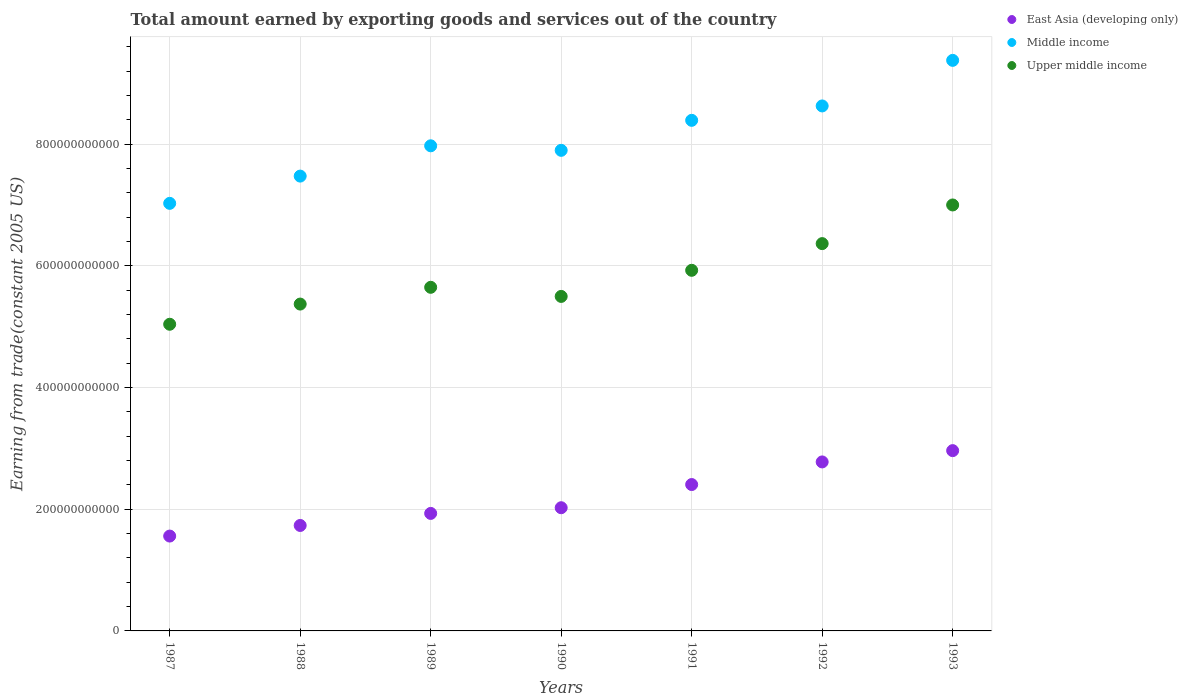What is the total amount earned by exporting goods and services in Upper middle income in 1992?
Offer a terse response. 6.36e+11. Across all years, what is the maximum total amount earned by exporting goods and services in East Asia (developing only)?
Your response must be concise. 2.96e+11. Across all years, what is the minimum total amount earned by exporting goods and services in Upper middle income?
Your response must be concise. 5.04e+11. In which year was the total amount earned by exporting goods and services in East Asia (developing only) minimum?
Provide a succinct answer. 1987. What is the total total amount earned by exporting goods and services in Upper middle income in the graph?
Ensure brevity in your answer.  4.08e+12. What is the difference between the total amount earned by exporting goods and services in Upper middle income in 1988 and that in 1991?
Offer a very short reply. -5.55e+1. What is the difference between the total amount earned by exporting goods and services in East Asia (developing only) in 1989 and the total amount earned by exporting goods and services in Middle income in 1987?
Your answer should be compact. -5.10e+11. What is the average total amount earned by exporting goods and services in Middle income per year?
Give a very brief answer. 8.11e+11. In the year 1990, what is the difference between the total amount earned by exporting goods and services in East Asia (developing only) and total amount earned by exporting goods and services in Upper middle income?
Your response must be concise. -3.47e+11. In how many years, is the total amount earned by exporting goods and services in East Asia (developing only) greater than 760000000000 US$?
Ensure brevity in your answer.  0. What is the ratio of the total amount earned by exporting goods and services in Middle income in 1991 to that in 1992?
Provide a succinct answer. 0.97. Is the total amount earned by exporting goods and services in Upper middle income in 1987 less than that in 1992?
Give a very brief answer. Yes. What is the difference between the highest and the second highest total amount earned by exporting goods and services in Upper middle income?
Keep it short and to the point. 6.35e+1. What is the difference between the highest and the lowest total amount earned by exporting goods and services in Middle income?
Offer a very short reply. 2.35e+11. In how many years, is the total amount earned by exporting goods and services in Upper middle income greater than the average total amount earned by exporting goods and services in Upper middle income taken over all years?
Your response must be concise. 3. Is the sum of the total amount earned by exporting goods and services in East Asia (developing only) in 1987 and 1988 greater than the maximum total amount earned by exporting goods and services in Middle income across all years?
Offer a very short reply. No. Is it the case that in every year, the sum of the total amount earned by exporting goods and services in East Asia (developing only) and total amount earned by exporting goods and services in Upper middle income  is greater than the total amount earned by exporting goods and services in Middle income?
Your answer should be compact. No. How many years are there in the graph?
Provide a short and direct response. 7. What is the difference between two consecutive major ticks on the Y-axis?
Your response must be concise. 2.00e+11. How are the legend labels stacked?
Your answer should be very brief. Vertical. What is the title of the graph?
Provide a succinct answer. Total amount earned by exporting goods and services out of the country. Does "Hong Kong" appear as one of the legend labels in the graph?
Provide a short and direct response. No. What is the label or title of the X-axis?
Give a very brief answer. Years. What is the label or title of the Y-axis?
Provide a short and direct response. Earning from trade(constant 2005 US). What is the Earning from trade(constant 2005 US) in East Asia (developing only) in 1987?
Give a very brief answer. 1.56e+11. What is the Earning from trade(constant 2005 US) in Middle income in 1987?
Your answer should be compact. 7.03e+11. What is the Earning from trade(constant 2005 US) in Upper middle income in 1987?
Ensure brevity in your answer.  5.04e+11. What is the Earning from trade(constant 2005 US) in East Asia (developing only) in 1988?
Your answer should be very brief. 1.73e+11. What is the Earning from trade(constant 2005 US) in Middle income in 1988?
Your answer should be very brief. 7.47e+11. What is the Earning from trade(constant 2005 US) of Upper middle income in 1988?
Your answer should be very brief. 5.37e+11. What is the Earning from trade(constant 2005 US) in East Asia (developing only) in 1989?
Your response must be concise. 1.93e+11. What is the Earning from trade(constant 2005 US) of Middle income in 1989?
Keep it short and to the point. 7.97e+11. What is the Earning from trade(constant 2005 US) in Upper middle income in 1989?
Provide a succinct answer. 5.65e+11. What is the Earning from trade(constant 2005 US) in East Asia (developing only) in 1990?
Make the answer very short. 2.02e+11. What is the Earning from trade(constant 2005 US) of Middle income in 1990?
Keep it short and to the point. 7.90e+11. What is the Earning from trade(constant 2005 US) of Upper middle income in 1990?
Offer a very short reply. 5.50e+11. What is the Earning from trade(constant 2005 US) of East Asia (developing only) in 1991?
Your answer should be compact. 2.41e+11. What is the Earning from trade(constant 2005 US) of Middle income in 1991?
Provide a succinct answer. 8.39e+11. What is the Earning from trade(constant 2005 US) in Upper middle income in 1991?
Ensure brevity in your answer.  5.93e+11. What is the Earning from trade(constant 2005 US) of East Asia (developing only) in 1992?
Provide a short and direct response. 2.78e+11. What is the Earning from trade(constant 2005 US) in Middle income in 1992?
Provide a short and direct response. 8.63e+11. What is the Earning from trade(constant 2005 US) in Upper middle income in 1992?
Offer a terse response. 6.36e+11. What is the Earning from trade(constant 2005 US) in East Asia (developing only) in 1993?
Ensure brevity in your answer.  2.96e+11. What is the Earning from trade(constant 2005 US) of Middle income in 1993?
Offer a terse response. 9.38e+11. What is the Earning from trade(constant 2005 US) of Upper middle income in 1993?
Make the answer very short. 7.00e+11. Across all years, what is the maximum Earning from trade(constant 2005 US) in East Asia (developing only)?
Make the answer very short. 2.96e+11. Across all years, what is the maximum Earning from trade(constant 2005 US) of Middle income?
Ensure brevity in your answer.  9.38e+11. Across all years, what is the maximum Earning from trade(constant 2005 US) in Upper middle income?
Offer a very short reply. 7.00e+11. Across all years, what is the minimum Earning from trade(constant 2005 US) of East Asia (developing only)?
Give a very brief answer. 1.56e+11. Across all years, what is the minimum Earning from trade(constant 2005 US) in Middle income?
Give a very brief answer. 7.03e+11. Across all years, what is the minimum Earning from trade(constant 2005 US) of Upper middle income?
Your response must be concise. 5.04e+11. What is the total Earning from trade(constant 2005 US) of East Asia (developing only) in the graph?
Keep it short and to the point. 1.54e+12. What is the total Earning from trade(constant 2005 US) in Middle income in the graph?
Give a very brief answer. 5.68e+12. What is the total Earning from trade(constant 2005 US) of Upper middle income in the graph?
Keep it short and to the point. 4.08e+12. What is the difference between the Earning from trade(constant 2005 US) in East Asia (developing only) in 1987 and that in 1988?
Provide a short and direct response. -1.74e+1. What is the difference between the Earning from trade(constant 2005 US) of Middle income in 1987 and that in 1988?
Ensure brevity in your answer.  -4.48e+1. What is the difference between the Earning from trade(constant 2005 US) in Upper middle income in 1987 and that in 1988?
Make the answer very short. -3.32e+1. What is the difference between the Earning from trade(constant 2005 US) of East Asia (developing only) in 1987 and that in 1989?
Offer a terse response. -3.72e+1. What is the difference between the Earning from trade(constant 2005 US) of Middle income in 1987 and that in 1989?
Provide a short and direct response. -9.46e+1. What is the difference between the Earning from trade(constant 2005 US) in Upper middle income in 1987 and that in 1989?
Make the answer very short. -6.07e+1. What is the difference between the Earning from trade(constant 2005 US) of East Asia (developing only) in 1987 and that in 1990?
Offer a very short reply. -4.66e+1. What is the difference between the Earning from trade(constant 2005 US) in Middle income in 1987 and that in 1990?
Your answer should be very brief. -8.71e+1. What is the difference between the Earning from trade(constant 2005 US) in Upper middle income in 1987 and that in 1990?
Offer a terse response. -4.58e+1. What is the difference between the Earning from trade(constant 2005 US) in East Asia (developing only) in 1987 and that in 1991?
Make the answer very short. -8.47e+1. What is the difference between the Earning from trade(constant 2005 US) in Middle income in 1987 and that in 1991?
Provide a succinct answer. -1.36e+11. What is the difference between the Earning from trade(constant 2005 US) of Upper middle income in 1987 and that in 1991?
Give a very brief answer. -8.87e+1. What is the difference between the Earning from trade(constant 2005 US) in East Asia (developing only) in 1987 and that in 1992?
Give a very brief answer. -1.22e+11. What is the difference between the Earning from trade(constant 2005 US) of Middle income in 1987 and that in 1992?
Give a very brief answer. -1.60e+11. What is the difference between the Earning from trade(constant 2005 US) in Upper middle income in 1987 and that in 1992?
Keep it short and to the point. -1.33e+11. What is the difference between the Earning from trade(constant 2005 US) in East Asia (developing only) in 1987 and that in 1993?
Give a very brief answer. -1.40e+11. What is the difference between the Earning from trade(constant 2005 US) in Middle income in 1987 and that in 1993?
Make the answer very short. -2.35e+11. What is the difference between the Earning from trade(constant 2005 US) in Upper middle income in 1987 and that in 1993?
Your answer should be very brief. -1.96e+11. What is the difference between the Earning from trade(constant 2005 US) of East Asia (developing only) in 1988 and that in 1989?
Provide a short and direct response. -1.98e+1. What is the difference between the Earning from trade(constant 2005 US) of Middle income in 1988 and that in 1989?
Make the answer very short. -4.98e+1. What is the difference between the Earning from trade(constant 2005 US) in Upper middle income in 1988 and that in 1989?
Provide a succinct answer. -2.75e+1. What is the difference between the Earning from trade(constant 2005 US) in East Asia (developing only) in 1988 and that in 1990?
Keep it short and to the point. -2.92e+1. What is the difference between the Earning from trade(constant 2005 US) of Middle income in 1988 and that in 1990?
Provide a succinct answer. -4.23e+1. What is the difference between the Earning from trade(constant 2005 US) in Upper middle income in 1988 and that in 1990?
Ensure brevity in your answer.  -1.26e+1. What is the difference between the Earning from trade(constant 2005 US) in East Asia (developing only) in 1988 and that in 1991?
Offer a terse response. -6.72e+1. What is the difference between the Earning from trade(constant 2005 US) of Middle income in 1988 and that in 1991?
Make the answer very short. -9.16e+1. What is the difference between the Earning from trade(constant 2005 US) of Upper middle income in 1988 and that in 1991?
Offer a very short reply. -5.55e+1. What is the difference between the Earning from trade(constant 2005 US) in East Asia (developing only) in 1988 and that in 1992?
Your answer should be compact. -1.04e+11. What is the difference between the Earning from trade(constant 2005 US) of Middle income in 1988 and that in 1992?
Your response must be concise. -1.15e+11. What is the difference between the Earning from trade(constant 2005 US) in Upper middle income in 1988 and that in 1992?
Ensure brevity in your answer.  -9.94e+1. What is the difference between the Earning from trade(constant 2005 US) in East Asia (developing only) in 1988 and that in 1993?
Offer a terse response. -1.23e+11. What is the difference between the Earning from trade(constant 2005 US) of Middle income in 1988 and that in 1993?
Provide a short and direct response. -1.90e+11. What is the difference between the Earning from trade(constant 2005 US) in Upper middle income in 1988 and that in 1993?
Your answer should be very brief. -1.63e+11. What is the difference between the Earning from trade(constant 2005 US) in East Asia (developing only) in 1989 and that in 1990?
Offer a very short reply. -9.35e+09. What is the difference between the Earning from trade(constant 2005 US) in Middle income in 1989 and that in 1990?
Ensure brevity in your answer.  7.45e+09. What is the difference between the Earning from trade(constant 2005 US) of Upper middle income in 1989 and that in 1990?
Your response must be concise. 1.50e+1. What is the difference between the Earning from trade(constant 2005 US) of East Asia (developing only) in 1989 and that in 1991?
Keep it short and to the point. -4.74e+1. What is the difference between the Earning from trade(constant 2005 US) in Middle income in 1989 and that in 1991?
Your answer should be compact. -4.19e+1. What is the difference between the Earning from trade(constant 2005 US) of Upper middle income in 1989 and that in 1991?
Provide a succinct answer. -2.79e+1. What is the difference between the Earning from trade(constant 2005 US) in East Asia (developing only) in 1989 and that in 1992?
Offer a very short reply. -8.46e+1. What is the difference between the Earning from trade(constant 2005 US) in Middle income in 1989 and that in 1992?
Provide a succinct answer. -6.55e+1. What is the difference between the Earning from trade(constant 2005 US) in Upper middle income in 1989 and that in 1992?
Provide a short and direct response. -7.18e+1. What is the difference between the Earning from trade(constant 2005 US) of East Asia (developing only) in 1989 and that in 1993?
Your answer should be very brief. -1.03e+11. What is the difference between the Earning from trade(constant 2005 US) in Middle income in 1989 and that in 1993?
Give a very brief answer. -1.40e+11. What is the difference between the Earning from trade(constant 2005 US) of Upper middle income in 1989 and that in 1993?
Your answer should be very brief. -1.35e+11. What is the difference between the Earning from trade(constant 2005 US) of East Asia (developing only) in 1990 and that in 1991?
Your answer should be compact. -3.81e+1. What is the difference between the Earning from trade(constant 2005 US) in Middle income in 1990 and that in 1991?
Your answer should be very brief. -4.93e+1. What is the difference between the Earning from trade(constant 2005 US) in Upper middle income in 1990 and that in 1991?
Keep it short and to the point. -4.29e+1. What is the difference between the Earning from trade(constant 2005 US) of East Asia (developing only) in 1990 and that in 1992?
Keep it short and to the point. -7.53e+1. What is the difference between the Earning from trade(constant 2005 US) in Middle income in 1990 and that in 1992?
Give a very brief answer. -7.30e+1. What is the difference between the Earning from trade(constant 2005 US) in Upper middle income in 1990 and that in 1992?
Offer a terse response. -8.68e+1. What is the difference between the Earning from trade(constant 2005 US) in East Asia (developing only) in 1990 and that in 1993?
Your answer should be compact. -9.38e+1. What is the difference between the Earning from trade(constant 2005 US) of Middle income in 1990 and that in 1993?
Provide a short and direct response. -1.48e+11. What is the difference between the Earning from trade(constant 2005 US) in Upper middle income in 1990 and that in 1993?
Your answer should be very brief. -1.50e+11. What is the difference between the Earning from trade(constant 2005 US) of East Asia (developing only) in 1991 and that in 1992?
Give a very brief answer. -3.72e+1. What is the difference between the Earning from trade(constant 2005 US) of Middle income in 1991 and that in 1992?
Offer a very short reply. -2.37e+1. What is the difference between the Earning from trade(constant 2005 US) of Upper middle income in 1991 and that in 1992?
Provide a short and direct response. -4.39e+1. What is the difference between the Earning from trade(constant 2005 US) in East Asia (developing only) in 1991 and that in 1993?
Keep it short and to the point. -5.57e+1. What is the difference between the Earning from trade(constant 2005 US) of Middle income in 1991 and that in 1993?
Your response must be concise. -9.86e+1. What is the difference between the Earning from trade(constant 2005 US) in Upper middle income in 1991 and that in 1993?
Make the answer very short. -1.07e+11. What is the difference between the Earning from trade(constant 2005 US) in East Asia (developing only) in 1992 and that in 1993?
Provide a succinct answer. -1.86e+1. What is the difference between the Earning from trade(constant 2005 US) in Middle income in 1992 and that in 1993?
Offer a terse response. -7.49e+1. What is the difference between the Earning from trade(constant 2005 US) of Upper middle income in 1992 and that in 1993?
Offer a very short reply. -6.35e+1. What is the difference between the Earning from trade(constant 2005 US) in East Asia (developing only) in 1987 and the Earning from trade(constant 2005 US) in Middle income in 1988?
Ensure brevity in your answer.  -5.92e+11. What is the difference between the Earning from trade(constant 2005 US) of East Asia (developing only) in 1987 and the Earning from trade(constant 2005 US) of Upper middle income in 1988?
Provide a short and direct response. -3.81e+11. What is the difference between the Earning from trade(constant 2005 US) in Middle income in 1987 and the Earning from trade(constant 2005 US) in Upper middle income in 1988?
Ensure brevity in your answer.  1.66e+11. What is the difference between the Earning from trade(constant 2005 US) of East Asia (developing only) in 1987 and the Earning from trade(constant 2005 US) of Middle income in 1989?
Your answer should be very brief. -6.41e+11. What is the difference between the Earning from trade(constant 2005 US) in East Asia (developing only) in 1987 and the Earning from trade(constant 2005 US) in Upper middle income in 1989?
Your answer should be very brief. -4.09e+11. What is the difference between the Earning from trade(constant 2005 US) of Middle income in 1987 and the Earning from trade(constant 2005 US) of Upper middle income in 1989?
Your answer should be compact. 1.38e+11. What is the difference between the Earning from trade(constant 2005 US) of East Asia (developing only) in 1987 and the Earning from trade(constant 2005 US) of Middle income in 1990?
Give a very brief answer. -6.34e+11. What is the difference between the Earning from trade(constant 2005 US) in East Asia (developing only) in 1987 and the Earning from trade(constant 2005 US) in Upper middle income in 1990?
Your answer should be very brief. -3.94e+11. What is the difference between the Earning from trade(constant 2005 US) of Middle income in 1987 and the Earning from trade(constant 2005 US) of Upper middle income in 1990?
Provide a succinct answer. 1.53e+11. What is the difference between the Earning from trade(constant 2005 US) in East Asia (developing only) in 1987 and the Earning from trade(constant 2005 US) in Middle income in 1991?
Make the answer very short. -6.83e+11. What is the difference between the Earning from trade(constant 2005 US) in East Asia (developing only) in 1987 and the Earning from trade(constant 2005 US) in Upper middle income in 1991?
Provide a succinct answer. -4.37e+11. What is the difference between the Earning from trade(constant 2005 US) in Middle income in 1987 and the Earning from trade(constant 2005 US) in Upper middle income in 1991?
Your answer should be compact. 1.10e+11. What is the difference between the Earning from trade(constant 2005 US) in East Asia (developing only) in 1987 and the Earning from trade(constant 2005 US) in Middle income in 1992?
Make the answer very short. -7.07e+11. What is the difference between the Earning from trade(constant 2005 US) of East Asia (developing only) in 1987 and the Earning from trade(constant 2005 US) of Upper middle income in 1992?
Give a very brief answer. -4.81e+11. What is the difference between the Earning from trade(constant 2005 US) in Middle income in 1987 and the Earning from trade(constant 2005 US) in Upper middle income in 1992?
Your response must be concise. 6.62e+1. What is the difference between the Earning from trade(constant 2005 US) in East Asia (developing only) in 1987 and the Earning from trade(constant 2005 US) in Middle income in 1993?
Your answer should be compact. -7.82e+11. What is the difference between the Earning from trade(constant 2005 US) of East Asia (developing only) in 1987 and the Earning from trade(constant 2005 US) of Upper middle income in 1993?
Offer a terse response. -5.44e+11. What is the difference between the Earning from trade(constant 2005 US) of Middle income in 1987 and the Earning from trade(constant 2005 US) of Upper middle income in 1993?
Make the answer very short. 2.65e+09. What is the difference between the Earning from trade(constant 2005 US) in East Asia (developing only) in 1988 and the Earning from trade(constant 2005 US) in Middle income in 1989?
Ensure brevity in your answer.  -6.24e+11. What is the difference between the Earning from trade(constant 2005 US) of East Asia (developing only) in 1988 and the Earning from trade(constant 2005 US) of Upper middle income in 1989?
Your answer should be compact. -3.91e+11. What is the difference between the Earning from trade(constant 2005 US) in Middle income in 1988 and the Earning from trade(constant 2005 US) in Upper middle income in 1989?
Offer a terse response. 1.83e+11. What is the difference between the Earning from trade(constant 2005 US) in East Asia (developing only) in 1988 and the Earning from trade(constant 2005 US) in Middle income in 1990?
Keep it short and to the point. -6.16e+11. What is the difference between the Earning from trade(constant 2005 US) in East Asia (developing only) in 1988 and the Earning from trade(constant 2005 US) in Upper middle income in 1990?
Provide a short and direct response. -3.76e+11. What is the difference between the Earning from trade(constant 2005 US) in Middle income in 1988 and the Earning from trade(constant 2005 US) in Upper middle income in 1990?
Your response must be concise. 1.98e+11. What is the difference between the Earning from trade(constant 2005 US) in East Asia (developing only) in 1988 and the Earning from trade(constant 2005 US) in Middle income in 1991?
Make the answer very short. -6.66e+11. What is the difference between the Earning from trade(constant 2005 US) in East Asia (developing only) in 1988 and the Earning from trade(constant 2005 US) in Upper middle income in 1991?
Your answer should be compact. -4.19e+11. What is the difference between the Earning from trade(constant 2005 US) of Middle income in 1988 and the Earning from trade(constant 2005 US) of Upper middle income in 1991?
Offer a very short reply. 1.55e+11. What is the difference between the Earning from trade(constant 2005 US) in East Asia (developing only) in 1988 and the Earning from trade(constant 2005 US) in Middle income in 1992?
Make the answer very short. -6.89e+11. What is the difference between the Earning from trade(constant 2005 US) of East Asia (developing only) in 1988 and the Earning from trade(constant 2005 US) of Upper middle income in 1992?
Offer a very short reply. -4.63e+11. What is the difference between the Earning from trade(constant 2005 US) in Middle income in 1988 and the Earning from trade(constant 2005 US) in Upper middle income in 1992?
Your answer should be very brief. 1.11e+11. What is the difference between the Earning from trade(constant 2005 US) in East Asia (developing only) in 1988 and the Earning from trade(constant 2005 US) in Middle income in 1993?
Offer a terse response. -7.64e+11. What is the difference between the Earning from trade(constant 2005 US) of East Asia (developing only) in 1988 and the Earning from trade(constant 2005 US) of Upper middle income in 1993?
Offer a terse response. -5.27e+11. What is the difference between the Earning from trade(constant 2005 US) in Middle income in 1988 and the Earning from trade(constant 2005 US) in Upper middle income in 1993?
Keep it short and to the point. 4.74e+1. What is the difference between the Earning from trade(constant 2005 US) of East Asia (developing only) in 1989 and the Earning from trade(constant 2005 US) of Middle income in 1990?
Provide a succinct answer. -5.97e+11. What is the difference between the Earning from trade(constant 2005 US) in East Asia (developing only) in 1989 and the Earning from trade(constant 2005 US) in Upper middle income in 1990?
Keep it short and to the point. -3.57e+11. What is the difference between the Earning from trade(constant 2005 US) of Middle income in 1989 and the Earning from trade(constant 2005 US) of Upper middle income in 1990?
Provide a succinct answer. 2.48e+11. What is the difference between the Earning from trade(constant 2005 US) in East Asia (developing only) in 1989 and the Earning from trade(constant 2005 US) in Middle income in 1991?
Keep it short and to the point. -6.46e+11. What is the difference between the Earning from trade(constant 2005 US) in East Asia (developing only) in 1989 and the Earning from trade(constant 2005 US) in Upper middle income in 1991?
Provide a short and direct response. -4.00e+11. What is the difference between the Earning from trade(constant 2005 US) in Middle income in 1989 and the Earning from trade(constant 2005 US) in Upper middle income in 1991?
Give a very brief answer. 2.05e+11. What is the difference between the Earning from trade(constant 2005 US) of East Asia (developing only) in 1989 and the Earning from trade(constant 2005 US) of Middle income in 1992?
Ensure brevity in your answer.  -6.70e+11. What is the difference between the Earning from trade(constant 2005 US) of East Asia (developing only) in 1989 and the Earning from trade(constant 2005 US) of Upper middle income in 1992?
Your response must be concise. -4.43e+11. What is the difference between the Earning from trade(constant 2005 US) in Middle income in 1989 and the Earning from trade(constant 2005 US) in Upper middle income in 1992?
Provide a succinct answer. 1.61e+11. What is the difference between the Earning from trade(constant 2005 US) of East Asia (developing only) in 1989 and the Earning from trade(constant 2005 US) of Middle income in 1993?
Ensure brevity in your answer.  -7.45e+11. What is the difference between the Earning from trade(constant 2005 US) of East Asia (developing only) in 1989 and the Earning from trade(constant 2005 US) of Upper middle income in 1993?
Offer a terse response. -5.07e+11. What is the difference between the Earning from trade(constant 2005 US) of Middle income in 1989 and the Earning from trade(constant 2005 US) of Upper middle income in 1993?
Your answer should be compact. 9.72e+1. What is the difference between the Earning from trade(constant 2005 US) in East Asia (developing only) in 1990 and the Earning from trade(constant 2005 US) in Middle income in 1991?
Provide a succinct answer. -6.37e+11. What is the difference between the Earning from trade(constant 2005 US) in East Asia (developing only) in 1990 and the Earning from trade(constant 2005 US) in Upper middle income in 1991?
Your answer should be very brief. -3.90e+11. What is the difference between the Earning from trade(constant 2005 US) in Middle income in 1990 and the Earning from trade(constant 2005 US) in Upper middle income in 1991?
Your response must be concise. 1.97e+11. What is the difference between the Earning from trade(constant 2005 US) in East Asia (developing only) in 1990 and the Earning from trade(constant 2005 US) in Middle income in 1992?
Ensure brevity in your answer.  -6.60e+11. What is the difference between the Earning from trade(constant 2005 US) of East Asia (developing only) in 1990 and the Earning from trade(constant 2005 US) of Upper middle income in 1992?
Your response must be concise. -4.34e+11. What is the difference between the Earning from trade(constant 2005 US) in Middle income in 1990 and the Earning from trade(constant 2005 US) in Upper middle income in 1992?
Give a very brief answer. 1.53e+11. What is the difference between the Earning from trade(constant 2005 US) in East Asia (developing only) in 1990 and the Earning from trade(constant 2005 US) in Middle income in 1993?
Your response must be concise. -7.35e+11. What is the difference between the Earning from trade(constant 2005 US) in East Asia (developing only) in 1990 and the Earning from trade(constant 2005 US) in Upper middle income in 1993?
Provide a short and direct response. -4.98e+11. What is the difference between the Earning from trade(constant 2005 US) of Middle income in 1990 and the Earning from trade(constant 2005 US) of Upper middle income in 1993?
Offer a very short reply. 8.98e+1. What is the difference between the Earning from trade(constant 2005 US) in East Asia (developing only) in 1991 and the Earning from trade(constant 2005 US) in Middle income in 1992?
Provide a succinct answer. -6.22e+11. What is the difference between the Earning from trade(constant 2005 US) in East Asia (developing only) in 1991 and the Earning from trade(constant 2005 US) in Upper middle income in 1992?
Ensure brevity in your answer.  -3.96e+11. What is the difference between the Earning from trade(constant 2005 US) of Middle income in 1991 and the Earning from trade(constant 2005 US) of Upper middle income in 1992?
Provide a short and direct response. 2.03e+11. What is the difference between the Earning from trade(constant 2005 US) of East Asia (developing only) in 1991 and the Earning from trade(constant 2005 US) of Middle income in 1993?
Ensure brevity in your answer.  -6.97e+11. What is the difference between the Earning from trade(constant 2005 US) in East Asia (developing only) in 1991 and the Earning from trade(constant 2005 US) in Upper middle income in 1993?
Your answer should be compact. -4.59e+11. What is the difference between the Earning from trade(constant 2005 US) of Middle income in 1991 and the Earning from trade(constant 2005 US) of Upper middle income in 1993?
Make the answer very short. 1.39e+11. What is the difference between the Earning from trade(constant 2005 US) of East Asia (developing only) in 1992 and the Earning from trade(constant 2005 US) of Middle income in 1993?
Provide a short and direct response. -6.60e+11. What is the difference between the Earning from trade(constant 2005 US) of East Asia (developing only) in 1992 and the Earning from trade(constant 2005 US) of Upper middle income in 1993?
Offer a terse response. -4.22e+11. What is the difference between the Earning from trade(constant 2005 US) of Middle income in 1992 and the Earning from trade(constant 2005 US) of Upper middle income in 1993?
Give a very brief answer. 1.63e+11. What is the average Earning from trade(constant 2005 US) in East Asia (developing only) per year?
Your response must be concise. 2.20e+11. What is the average Earning from trade(constant 2005 US) of Middle income per year?
Keep it short and to the point. 8.11e+11. What is the average Earning from trade(constant 2005 US) of Upper middle income per year?
Make the answer very short. 5.84e+11. In the year 1987, what is the difference between the Earning from trade(constant 2005 US) in East Asia (developing only) and Earning from trade(constant 2005 US) in Middle income?
Your answer should be compact. -5.47e+11. In the year 1987, what is the difference between the Earning from trade(constant 2005 US) in East Asia (developing only) and Earning from trade(constant 2005 US) in Upper middle income?
Make the answer very short. -3.48e+11. In the year 1987, what is the difference between the Earning from trade(constant 2005 US) of Middle income and Earning from trade(constant 2005 US) of Upper middle income?
Ensure brevity in your answer.  1.99e+11. In the year 1988, what is the difference between the Earning from trade(constant 2005 US) of East Asia (developing only) and Earning from trade(constant 2005 US) of Middle income?
Your response must be concise. -5.74e+11. In the year 1988, what is the difference between the Earning from trade(constant 2005 US) in East Asia (developing only) and Earning from trade(constant 2005 US) in Upper middle income?
Your answer should be compact. -3.64e+11. In the year 1988, what is the difference between the Earning from trade(constant 2005 US) in Middle income and Earning from trade(constant 2005 US) in Upper middle income?
Your answer should be very brief. 2.10e+11. In the year 1989, what is the difference between the Earning from trade(constant 2005 US) of East Asia (developing only) and Earning from trade(constant 2005 US) of Middle income?
Your response must be concise. -6.04e+11. In the year 1989, what is the difference between the Earning from trade(constant 2005 US) of East Asia (developing only) and Earning from trade(constant 2005 US) of Upper middle income?
Provide a short and direct response. -3.72e+11. In the year 1989, what is the difference between the Earning from trade(constant 2005 US) of Middle income and Earning from trade(constant 2005 US) of Upper middle income?
Provide a short and direct response. 2.33e+11. In the year 1990, what is the difference between the Earning from trade(constant 2005 US) of East Asia (developing only) and Earning from trade(constant 2005 US) of Middle income?
Make the answer very short. -5.87e+11. In the year 1990, what is the difference between the Earning from trade(constant 2005 US) of East Asia (developing only) and Earning from trade(constant 2005 US) of Upper middle income?
Your response must be concise. -3.47e+11. In the year 1990, what is the difference between the Earning from trade(constant 2005 US) of Middle income and Earning from trade(constant 2005 US) of Upper middle income?
Keep it short and to the point. 2.40e+11. In the year 1991, what is the difference between the Earning from trade(constant 2005 US) in East Asia (developing only) and Earning from trade(constant 2005 US) in Middle income?
Offer a terse response. -5.99e+11. In the year 1991, what is the difference between the Earning from trade(constant 2005 US) in East Asia (developing only) and Earning from trade(constant 2005 US) in Upper middle income?
Provide a short and direct response. -3.52e+11. In the year 1991, what is the difference between the Earning from trade(constant 2005 US) of Middle income and Earning from trade(constant 2005 US) of Upper middle income?
Keep it short and to the point. 2.46e+11. In the year 1992, what is the difference between the Earning from trade(constant 2005 US) in East Asia (developing only) and Earning from trade(constant 2005 US) in Middle income?
Give a very brief answer. -5.85e+11. In the year 1992, what is the difference between the Earning from trade(constant 2005 US) of East Asia (developing only) and Earning from trade(constant 2005 US) of Upper middle income?
Provide a short and direct response. -3.59e+11. In the year 1992, what is the difference between the Earning from trade(constant 2005 US) of Middle income and Earning from trade(constant 2005 US) of Upper middle income?
Your response must be concise. 2.26e+11. In the year 1993, what is the difference between the Earning from trade(constant 2005 US) of East Asia (developing only) and Earning from trade(constant 2005 US) of Middle income?
Give a very brief answer. -6.41e+11. In the year 1993, what is the difference between the Earning from trade(constant 2005 US) in East Asia (developing only) and Earning from trade(constant 2005 US) in Upper middle income?
Keep it short and to the point. -4.04e+11. In the year 1993, what is the difference between the Earning from trade(constant 2005 US) in Middle income and Earning from trade(constant 2005 US) in Upper middle income?
Ensure brevity in your answer.  2.38e+11. What is the ratio of the Earning from trade(constant 2005 US) of East Asia (developing only) in 1987 to that in 1988?
Your response must be concise. 0.9. What is the ratio of the Earning from trade(constant 2005 US) in Middle income in 1987 to that in 1988?
Your response must be concise. 0.94. What is the ratio of the Earning from trade(constant 2005 US) of Upper middle income in 1987 to that in 1988?
Offer a terse response. 0.94. What is the ratio of the Earning from trade(constant 2005 US) in East Asia (developing only) in 1987 to that in 1989?
Your answer should be very brief. 0.81. What is the ratio of the Earning from trade(constant 2005 US) in Middle income in 1987 to that in 1989?
Your response must be concise. 0.88. What is the ratio of the Earning from trade(constant 2005 US) of Upper middle income in 1987 to that in 1989?
Give a very brief answer. 0.89. What is the ratio of the Earning from trade(constant 2005 US) of East Asia (developing only) in 1987 to that in 1990?
Your response must be concise. 0.77. What is the ratio of the Earning from trade(constant 2005 US) of Middle income in 1987 to that in 1990?
Your answer should be very brief. 0.89. What is the ratio of the Earning from trade(constant 2005 US) of Upper middle income in 1987 to that in 1990?
Your answer should be very brief. 0.92. What is the ratio of the Earning from trade(constant 2005 US) in East Asia (developing only) in 1987 to that in 1991?
Your answer should be compact. 0.65. What is the ratio of the Earning from trade(constant 2005 US) of Middle income in 1987 to that in 1991?
Offer a terse response. 0.84. What is the ratio of the Earning from trade(constant 2005 US) in Upper middle income in 1987 to that in 1991?
Your response must be concise. 0.85. What is the ratio of the Earning from trade(constant 2005 US) in East Asia (developing only) in 1987 to that in 1992?
Make the answer very short. 0.56. What is the ratio of the Earning from trade(constant 2005 US) in Middle income in 1987 to that in 1992?
Ensure brevity in your answer.  0.81. What is the ratio of the Earning from trade(constant 2005 US) of Upper middle income in 1987 to that in 1992?
Your answer should be very brief. 0.79. What is the ratio of the Earning from trade(constant 2005 US) of East Asia (developing only) in 1987 to that in 1993?
Offer a very short reply. 0.53. What is the ratio of the Earning from trade(constant 2005 US) in Middle income in 1987 to that in 1993?
Your response must be concise. 0.75. What is the ratio of the Earning from trade(constant 2005 US) of Upper middle income in 1987 to that in 1993?
Keep it short and to the point. 0.72. What is the ratio of the Earning from trade(constant 2005 US) in East Asia (developing only) in 1988 to that in 1989?
Give a very brief answer. 0.9. What is the ratio of the Earning from trade(constant 2005 US) in Upper middle income in 1988 to that in 1989?
Your answer should be compact. 0.95. What is the ratio of the Earning from trade(constant 2005 US) in East Asia (developing only) in 1988 to that in 1990?
Your response must be concise. 0.86. What is the ratio of the Earning from trade(constant 2005 US) of Middle income in 1988 to that in 1990?
Your answer should be very brief. 0.95. What is the ratio of the Earning from trade(constant 2005 US) in Upper middle income in 1988 to that in 1990?
Provide a short and direct response. 0.98. What is the ratio of the Earning from trade(constant 2005 US) in East Asia (developing only) in 1988 to that in 1991?
Offer a terse response. 0.72. What is the ratio of the Earning from trade(constant 2005 US) of Middle income in 1988 to that in 1991?
Ensure brevity in your answer.  0.89. What is the ratio of the Earning from trade(constant 2005 US) in Upper middle income in 1988 to that in 1991?
Offer a terse response. 0.91. What is the ratio of the Earning from trade(constant 2005 US) of East Asia (developing only) in 1988 to that in 1992?
Ensure brevity in your answer.  0.62. What is the ratio of the Earning from trade(constant 2005 US) of Middle income in 1988 to that in 1992?
Keep it short and to the point. 0.87. What is the ratio of the Earning from trade(constant 2005 US) of Upper middle income in 1988 to that in 1992?
Offer a very short reply. 0.84. What is the ratio of the Earning from trade(constant 2005 US) in East Asia (developing only) in 1988 to that in 1993?
Offer a very short reply. 0.58. What is the ratio of the Earning from trade(constant 2005 US) in Middle income in 1988 to that in 1993?
Give a very brief answer. 0.8. What is the ratio of the Earning from trade(constant 2005 US) in Upper middle income in 1988 to that in 1993?
Offer a terse response. 0.77. What is the ratio of the Earning from trade(constant 2005 US) in East Asia (developing only) in 1989 to that in 1990?
Your response must be concise. 0.95. What is the ratio of the Earning from trade(constant 2005 US) of Middle income in 1989 to that in 1990?
Ensure brevity in your answer.  1.01. What is the ratio of the Earning from trade(constant 2005 US) in Upper middle income in 1989 to that in 1990?
Give a very brief answer. 1.03. What is the ratio of the Earning from trade(constant 2005 US) of East Asia (developing only) in 1989 to that in 1991?
Offer a terse response. 0.8. What is the ratio of the Earning from trade(constant 2005 US) of Middle income in 1989 to that in 1991?
Provide a succinct answer. 0.95. What is the ratio of the Earning from trade(constant 2005 US) of Upper middle income in 1989 to that in 1991?
Give a very brief answer. 0.95. What is the ratio of the Earning from trade(constant 2005 US) of East Asia (developing only) in 1989 to that in 1992?
Make the answer very short. 0.7. What is the ratio of the Earning from trade(constant 2005 US) of Middle income in 1989 to that in 1992?
Your answer should be compact. 0.92. What is the ratio of the Earning from trade(constant 2005 US) of Upper middle income in 1989 to that in 1992?
Provide a short and direct response. 0.89. What is the ratio of the Earning from trade(constant 2005 US) in East Asia (developing only) in 1989 to that in 1993?
Give a very brief answer. 0.65. What is the ratio of the Earning from trade(constant 2005 US) of Middle income in 1989 to that in 1993?
Ensure brevity in your answer.  0.85. What is the ratio of the Earning from trade(constant 2005 US) of Upper middle income in 1989 to that in 1993?
Give a very brief answer. 0.81. What is the ratio of the Earning from trade(constant 2005 US) of East Asia (developing only) in 1990 to that in 1991?
Your answer should be very brief. 0.84. What is the ratio of the Earning from trade(constant 2005 US) of Middle income in 1990 to that in 1991?
Give a very brief answer. 0.94. What is the ratio of the Earning from trade(constant 2005 US) in Upper middle income in 1990 to that in 1991?
Offer a very short reply. 0.93. What is the ratio of the Earning from trade(constant 2005 US) of East Asia (developing only) in 1990 to that in 1992?
Offer a terse response. 0.73. What is the ratio of the Earning from trade(constant 2005 US) of Middle income in 1990 to that in 1992?
Offer a very short reply. 0.92. What is the ratio of the Earning from trade(constant 2005 US) in Upper middle income in 1990 to that in 1992?
Keep it short and to the point. 0.86. What is the ratio of the Earning from trade(constant 2005 US) of East Asia (developing only) in 1990 to that in 1993?
Provide a short and direct response. 0.68. What is the ratio of the Earning from trade(constant 2005 US) in Middle income in 1990 to that in 1993?
Your answer should be very brief. 0.84. What is the ratio of the Earning from trade(constant 2005 US) of Upper middle income in 1990 to that in 1993?
Provide a short and direct response. 0.79. What is the ratio of the Earning from trade(constant 2005 US) of East Asia (developing only) in 1991 to that in 1992?
Your response must be concise. 0.87. What is the ratio of the Earning from trade(constant 2005 US) in Middle income in 1991 to that in 1992?
Offer a very short reply. 0.97. What is the ratio of the Earning from trade(constant 2005 US) of Upper middle income in 1991 to that in 1992?
Provide a short and direct response. 0.93. What is the ratio of the Earning from trade(constant 2005 US) in East Asia (developing only) in 1991 to that in 1993?
Your response must be concise. 0.81. What is the ratio of the Earning from trade(constant 2005 US) of Middle income in 1991 to that in 1993?
Offer a terse response. 0.89. What is the ratio of the Earning from trade(constant 2005 US) in Upper middle income in 1991 to that in 1993?
Keep it short and to the point. 0.85. What is the ratio of the Earning from trade(constant 2005 US) in East Asia (developing only) in 1992 to that in 1993?
Offer a very short reply. 0.94. What is the ratio of the Earning from trade(constant 2005 US) of Middle income in 1992 to that in 1993?
Provide a succinct answer. 0.92. What is the ratio of the Earning from trade(constant 2005 US) of Upper middle income in 1992 to that in 1993?
Offer a terse response. 0.91. What is the difference between the highest and the second highest Earning from trade(constant 2005 US) in East Asia (developing only)?
Make the answer very short. 1.86e+1. What is the difference between the highest and the second highest Earning from trade(constant 2005 US) of Middle income?
Provide a short and direct response. 7.49e+1. What is the difference between the highest and the second highest Earning from trade(constant 2005 US) of Upper middle income?
Your response must be concise. 6.35e+1. What is the difference between the highest and the lowest Earning from trade(constant 2005 US) of East Asia (developing only)?
Offer a terse response. 1.40e+11. What is the difference between the highest and the lowest Earning from trade(constant 2005 US) of Middle income?
Your answer should be very brief. 2.35e+11. What is the difference between the highest and the lowest Earning from trade(constant 2005 US) in Upper middle income?
Your answer should be compact. 1.96e+11. 